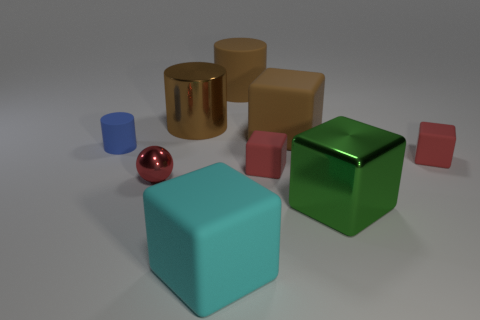Subtract all small cubes. How many cubes are left? 3 Subtract 1 cylinders. How many cylinders are left? 2 Subtract all blue balls. How many brown cylinders are left? 2 Subtract all cyan cubes. How many cubes are left? 4 Add 1 tiny metal spheres. How many objects exist? 10 Subtract all cyan blocks. Subtract all gray balls. How many blocks are left? 4 Add 4 tiny red rubber blocks. How many tiny red rubber blocks exist? 6 Subtract 0 blue cubes. How many objects are left? 9 Subtract all balls. How many objects are left? 8 Subtract all large metallic objects. Subtract all small rubber cubes. How many objects are left? 5 